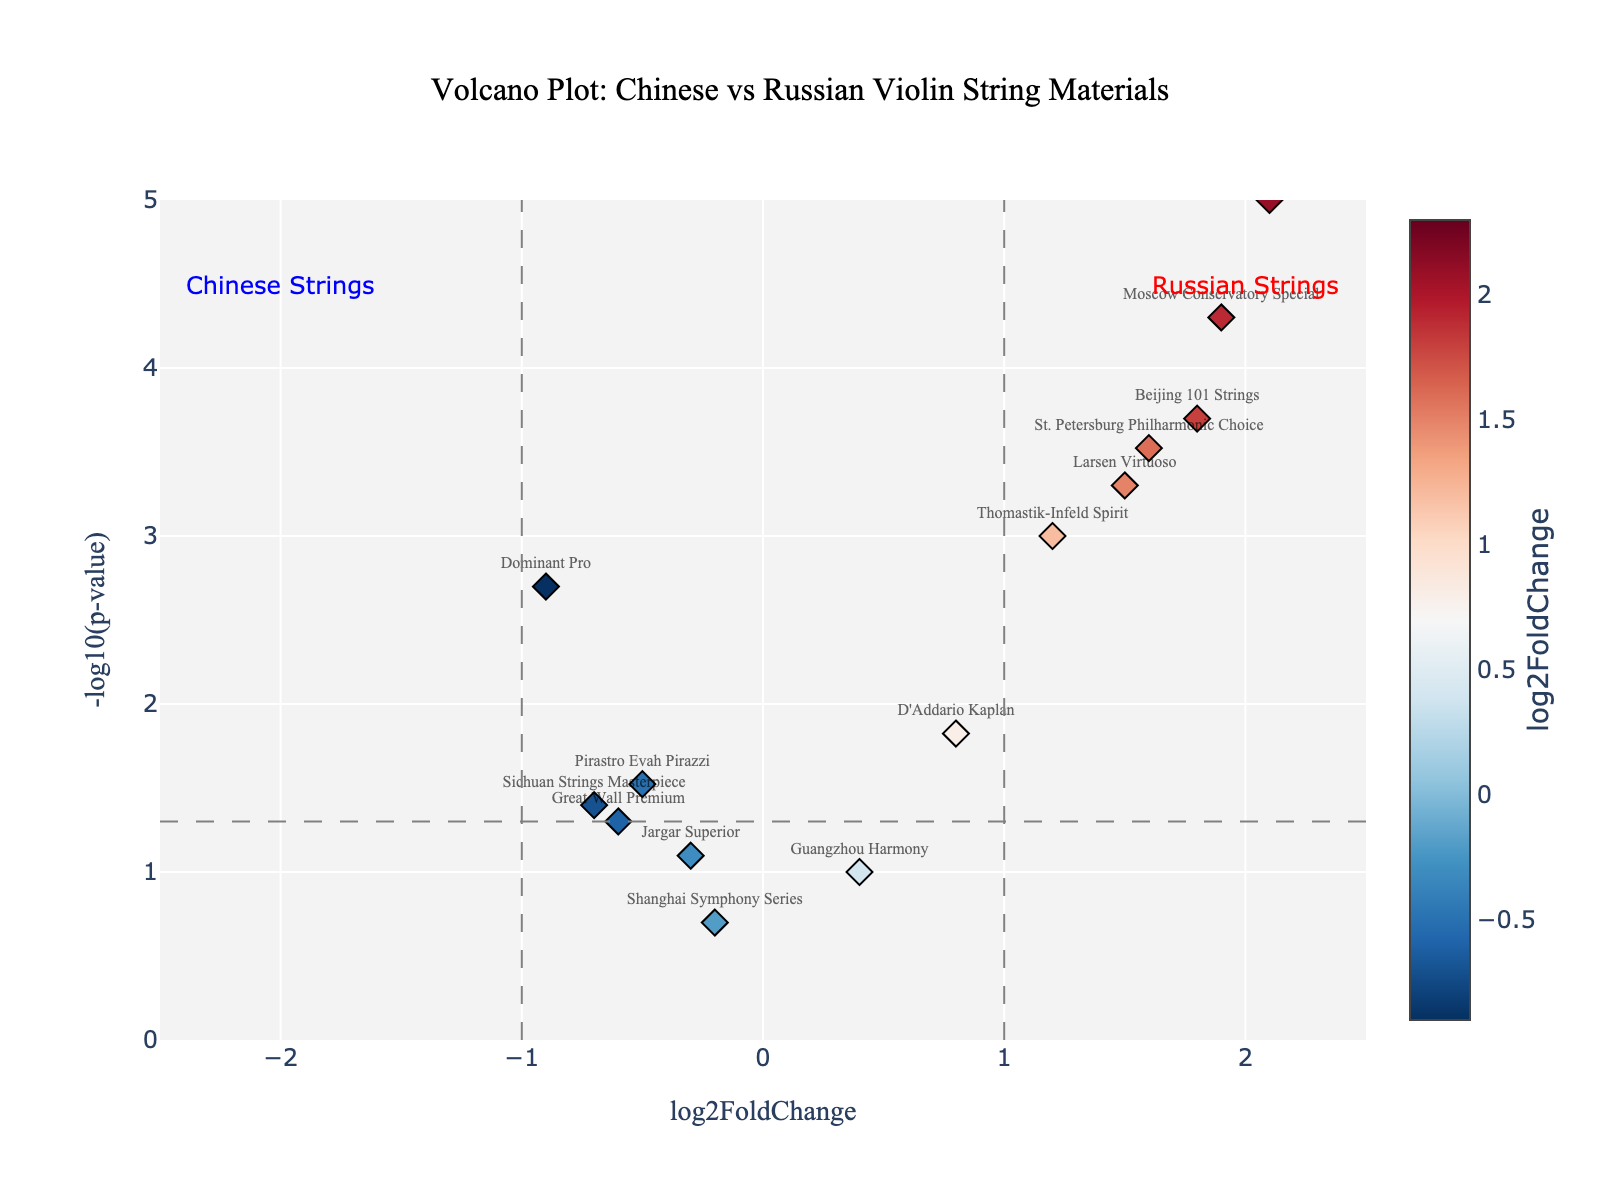How many data points are shown in the plot? There are 15 unique violin string materials listed in the data. Each material corresponds to a data point in the plot.
Answer: 15 What is the title of the plot? The title is centered at the top and reads "Volcano Plot: Chinese vs Russian Violin String Materials".
Answer: Volcano Plot: Chinese vs Russian Violin String Materials Which material has the highest log2FoldChange value? By identifying the data point with the highest x-axis value (log2FoldChange), we find it labeled as Tchaikovsky Tribute with a log2FoldChange of 2.3.
Answer: Tchaikovsky Tribute Are there any data points with a p-value greater than 0.05? Data points with p-values greater than 0.05 will have a -log10(p-value) less than 1. The materials "Guangzhou Harmony" and "Shanghai Symphony Series" fall into this category.
Answer: Yes Which material has the lowest -log10(p-value), indicating the highest p-value in the plot? The material with the lowest y-axis value (-log10(p-value)) is "Shanghai Symphony Series", meaning it has the highest p-value.
Answer: Shanghai Symphony Series How do the Chinese string materials compare to the Russian ones in terms of log2FoldChange values? Most Chinese string materials (Beijing 101 Strings, Sichuan Strings Masterpiece, Shanghai Symphony Series, Great Wall Premium) have lower or negative log2FoldChange values, while Russian strings (Russian Violin String Co. Classic, Moscow Conservatory Special, St. Petersburg Philharmonic Choice, Tchaikovsky Tribute) have higher positive values.
Answer: Chinese strings generally have lower log2FoldChange values compared to Russian strings What is the log2FoldChange value for "Moscow Conservatory Special"? Locate the data point labeled "Moscow Conservatory Special" on the plot; its x-axis value is 1.9.
Answer: 1.9 Which materials have a -log10(p-value) less than 1 (indicating p-values greater than 0.1)? Materials with y-axis values less than 1 are "Jargar Superior", "Guangzhou Harmony", and "Shanghai Symphony Series".
Answer: Jargar Superior, Guangzhou Harmony, Shanghai Symphony Series Among the materials with log2FoldChange greater than 1, which has the smallest -log10(p-value) value? Focus on materials with an x-axis value greater than 1 and identify the one with the smallest y-axis value (log2FoldChange values: Russian Violin String Co. Classic, Moscow Conservatory Special, Larsen Virtuoso, St. Petersburg Philharmonic Choice, Beijing 101 Strings, Tchaikovsky Tribute). "Larsen Virtuoso" has the smallest -log10(p-value) at 3.3.
Answer: Larsen Virtuoso 